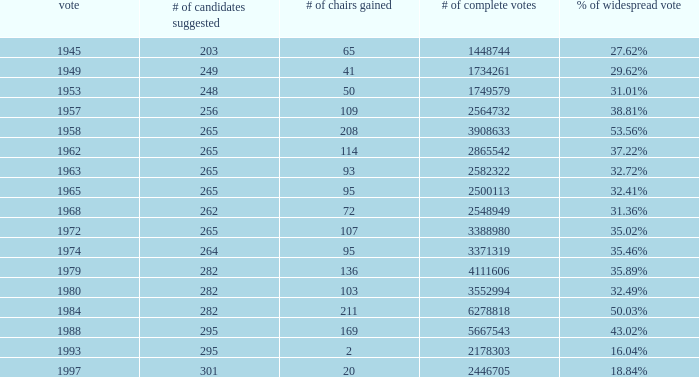How many times was the # of total votes 2582322? 1.0. 